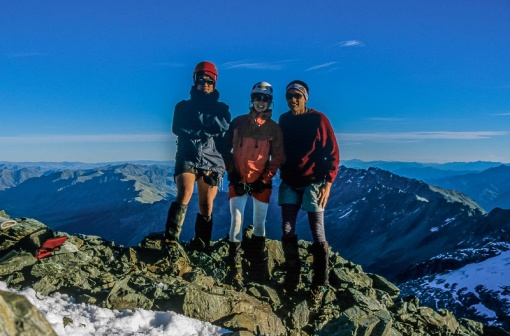Can you elaborate on the elements of the picture provided? In the image, three adventurers stand triumphantly on a rocky mountain peak, their smiles radiating joy and accomplishment under the vast, clear blue sky. Behind them, a breathtaking panorama of rugged mountains stretches as far as the eye can see, emphasizing the grandeur of their journey.

The adventurer on the left is dressed in a black jacket and shorts, complemented by a red helmet that hints at their courage and adventurous spirit. The middle adventurer, sporting a blue jacket and vibrant red pants, dons a white helmet, which might symbolically suggest a balanced, peacemaking role within the group. Completing the trio, the adventurer on the right wears a red jacket and black pants, paired with a matching red helmet. Each of them is also equipped with sunglasses, essential for protecting their eyes from the brilliant sunlight.

Their attire creates a vivid contrast against the rugged terrain and snow-patched rocks, with their joyful expressions and relaxed posture capturing a moment of success and camaraderie. This image encapsulates their shared struggle, resilience, and ultimate triumph, all set against the awe-inspiring backdrop of the mountain range. It's more than just a snapshot—it's a celebration of human spirit and the joy of overcoming challenges. 